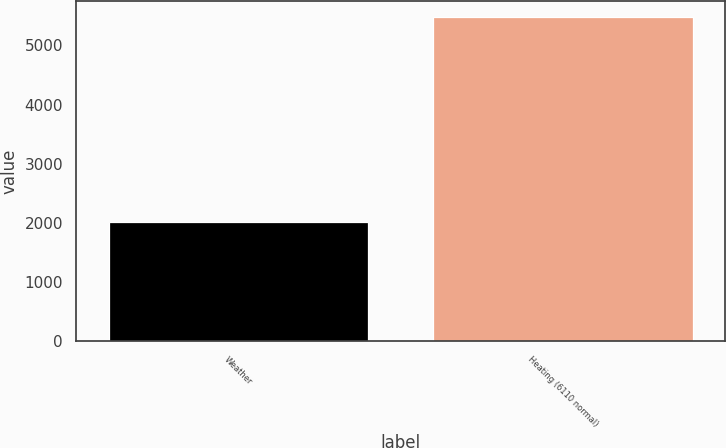<chart> <loc_0><loc_0><loc_500><loc_500><bar_chart><fcel>Weather<fcel>Heating (6110 normal)<nl><fcel>2017<fcel>5470<nl></chart> 